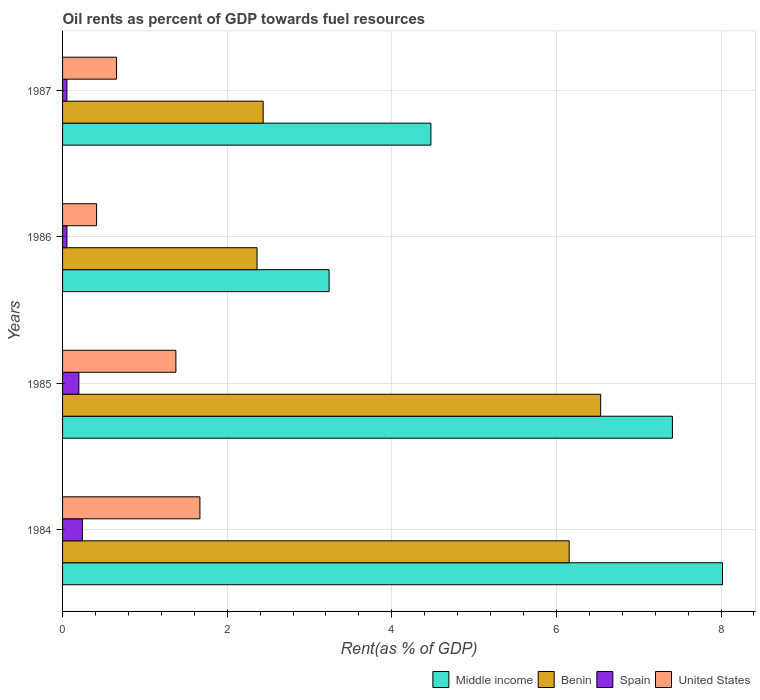How many different coloured bars are there?
Your answer should be compact. 4. How many groups of bars are there?
Ensure brevity in your answer.  4. Are the number of bars per tick equal to the number of legend labels?
Your answer should be compact. Yes. How many bars are there on the 2nd tick from the top?
Provide a short and direct response. 4. In how many cases, is the number of bars for a given year not equal to the number of legend labels?
Make the answer very short. 0. What is the oil rent in Benin in 1987?
Your answer should be compact. 2.44. Across all years, what is the maximum oil rent in Spain?
Your answer should be very brief. 0.24. Across all years, what is the minimum oil rent in United States?
Your response must be concise. 0.41. In which year was the oil rent in Spain maximum?
Your answer should be very brief. 1984. What is the total oil rent in Spain in the graph?
Keep it short and to the point. 0.55. What is the difference between the oil rent in Benin in 1984 and that in 1987?
Provide a short and direct response. 3.72. What is the difference between the oil rent in Benin in 1985 and the oil rent in Spain in 1986?
Give a very brief answer. 6.48. What is the average oil rent in United States per year?
Offer a very short reply. 1.03. In the year 1987, what is the difference between the oil rent in United States and oil rent in Spain?
Ensure brevity in your answer.  0.6. What is the ratio of the oil rent in Benin in 1984 to that in 1986?
Your response must be concise. 2.6. Is the difference between the oil rent in United States in 1984 and 1987 greater than the difference between the oil rent in Spain in 1984 and 1987?
Keep it short and to the point. Yes. What is the difference between the highest and the second highest oil rent in Spain?
Make the answer very short. 0.04. What is the difference between the highest and the lowest oil rent in United States?
Your answer should be compact. 1.26. Is it the case that in every year, the sum of the oil rent in United States and oil rent in Spain is greater than the oil rent in Benin?
Make the answer very short. No. What is the difference between two consecutive major ticks on the X-axis?
Give a very brief answer. 2. Are the values on the major ticks of X-axis written in scientific E-notation?
Give a very brief answer. No. Where does the legend appear in the graph?
Offer a terse response. Bottom right. What is the title of the graph?
Give a very brief answer. Oil rents as percent of GDP towards fuel resources. Does "Trinidad and Tobago" appear as one of the legend labels in the graph?
Keep it short and to the point. No. What is the label or title of the X-axis?
Keep it short and to the point. Rent(as % of GDP). What is the Rent(as % of GDP) in Middle income in 1984?
Give a very brief answer. 8.02. What is the Rent(as % of GDP) of Benin in 1984?
Your answer should be very brief. 6.16. What is the Rent(as % of GDP) of Spain in 1984?
Provide a succinct answer. 0.24. What is the Rent(as % of GDP) of United States in 1984?
Provide a short and direct response. 1.67. What is the Rent(as % of GDP) in Middle income in 1985?
Make the answer very short. 7.41. What is the Rent(as % of GDP) in Benin in 1985?
Provide a succinct answer. 6.54. What is the Rent(as % of GDP) in Spain in 1985?
Make the answer very short. 0.2. What is the Rent(as % of GDP) in United States in 1985?
Make the answer very short. 1.38. What is the Rent(as % of GDP) in Middle income in 1986?
Offer a very short reply. 3.24. What is the Rent(as % of GDP) in Benin in 1986?
Your answer should be very brief. 2.36. What is the Rent(as % of GDP) of Spain in 1986?
Your answer should be compact. 0.05. What is the Rent(as % of GDP) in United States in 1986?
Ensure brevity in your answer.  0.41. What is the Rent(as % of GDP) in Middle income in 1987?
Keep it short and to the point. 4.48. What is the Rent(as % of GDP) of Benin in 1987?
Make the answer very short. 2.44. What is the Rent(as % of GDP) of Spain in 1987?
Keep it short and to the point. 0.05. What is the Rent(as % of GDP) in United States in 1987?
Your answer should be very brief. 0.66. Across all years, what is the maximum Rent(as % of GDP) in Middle income?
Offer a terse response. 8.02. Across all years, what is the maximum Rent(as % of GDP) in Benin?
Provide a short and direct response. 6.54. Across all years, what is the maximum Rent(as % of GDP) of Spain?
Your answer should be compact. 0.24. Across all years, what is the maximum Rent(as % of GDP) of United States?
Make the answer very short. 1.67. Across all years, what is the minimum Rent(as % of GDP) in Middle income?
Offer a terse response. 3.24. Across all years, what is the minimum Rent(as % of GDP) in Benin?
Make the answer very short. 2.36. Across all years, what is the minimum Rent(as % of GDP) of Spain?
Your answer should be very brief. 0.05. Across all years, what is the minimum Rent(as % of GDP) of United States?
Provide a short and direct response. 0.41. What is the total Rent(as % of GDP) in Middle income in the graph?
Offer a terse response. 23.14. What is the total Rent(as % of GDP) of Benin in the graph?
Ensure brevity in your answer.  17.49. What is the total Rent(as % of GDP) in Spain in the graph?
Offer a very short reply. 0.55. What is the total Rent(as % of GDP) of United States in the graph?
Provide a short and direct response. 4.11. What is the difference between the Rent(as % of GDP) in Middle income in 1984 and that in 1985?
Offer a terse response. 0.61. What is the difference between the Rent(as % of GDP) of Benin in 1984 and that in 1985?
Provide a short and direct response. -0.38. What is the difference between the Rent(as % of GDP) of Spain in 1984 and that in 1985?
Offer a terse response. 0.04. What is the difference between the Rent(as % of GDP) in United States in 1984 and that in 1985?
Your answer should be very brief. 0.29. What is the difference between the Rent(as % of GDP) in Middle income in 1984 and that in 1986?
Offer a terse response. 4.78. What is the difference between the Rent(as % of GDP) in Benin in 1984 and that in 1986?
Offer a terse response. 3.79. What is the difference between the Rent(as % of GDP) in Spain in 1984 and that in 1986?
Ensure brevity in your answer.  0.19. What is the difference between the Rent(as % of GDP) in United States in 1984 and that in 1986?
Your answer should be very brief. 1.26. What is the difference between the Rent(as % of GDP) in Middle income in 1984 and that in 1987?
Keep it short and to the point. 3.54. What is the difference between the Rent(as % of GDP) of Benin in 1984 and that in 1987?
Ensure brevity in your answer.  3.72. What is the difference between the Rent(as % of GDP) in Spain in 1984 and that in 1987?
Ensure brevity in your answer.  0.19. What is the difference between the Rent(as % of GDP) in United States in 1984 and that in 1987?
Keep it short and to the point. 1.01. What is the difference between the Rent(as % of GDP) in Middle income in 1985 and that in 1986?
Your answer should be very brief. 4.17. What is the difference between the Rent(as % of GDP) in Benin in 1985 and that in 1986?
Give a very brief answer. 4.17. What is the difference between the Rent(as % of GDP) in Spain in 1985 and that in 1986?
Offer a very short reply. 0.15. What is the difference between the Rent(as % of GDP) of United States in 1985 and that in 1986?
Your response must be concise. 0.96. What is the difference between the Rent(as % of GDP) of Middle income in 1985 and that in 1987?
Provide a succinct answer. 2.93. What is the difference between the Rent(as % of GDP) of Benin in 1985 and that in 1987?
Offer a terse response. 4.1. What is the difference between the Rent(as % of GDP) in Spain in 1985 and that in 1987?
Provide a short and direct response. 0.15. What is the difference between the Rent(as % of GDP) of United States in 1985 and that in 1987?
Offer a very short reply. 0.72. What is the difference between the Rent(as % of GDP) of Middle income in 1986 and that in 1987?
Give a very brief answer. -1.24. What is the difference between the Rent(as % of GDP) in Benin in 1986 and that in 1987?
Your answer should be compact. -0.07. What is the difference between the Rent(as % of GDP) of United States in 1986 and that in 1987?
Offer a very short reply. -0.24. What is the difference between the Rent(as % of GDP) in Middle income in 1984 and the Rent(as % of GDP) in Benin in 1985?
Your response must be concise. 1.48. What is the difference between the Rent(as % of GDP) in Middle income in 1984 and the Rent(as % of GDP) in Spain in 1985?
Provide a succinct answer. 7.82. What is the difference between the Rent(as % of GDP) of Middle income in 1984 and the Rent(as % of GDP) of United States in 1985?
Give a very brief answer. 6.64. What is the difference between the Rent(as % of GDP) in Benin in 1984 and the Rent(as % of GDP) in Spain in 1985?
Offer a very short reply. 5.96. What is the difference between the Rent(as % of GDP) in Benin in 1984 and the Rent(as % of GDP) in United States in 1985?
Make the answer very short. 4.78. What is the difference between the Rent(as % of GDP) of Spain in 1984 and the Rent(as % of GDP) of United States in 1985?
Give a very brief answer. -1.14. What is the difference between the Rent(as % of GDP) of Middle income in 1984 and the Rent(as % of GDP) of Benin in 1986?
Offer a very short reply. 5.66. What is the difference between the Rent(as % of GDP) of Middle income in 1984 and the Rent(as % of GDP) of Spain in 1986?
Your response must be concise. 7.96. What is the difference between the Rent(as % of GDP) of Middle income in 1984 and the Rent(as % of GDP) of United States in 1986?
Ensure brevity in your answer.  7.6. What is the difference between the Rent(as % of GDP) of Benin in 1984 and the Rent(as % of GDP) of Spain in 1986?
Your answer should be compact. 6.1. What is the difference between the Rent(as % of GDP) in Benin in 1984 and the Rent(as % of GDP) in United States in 1986?
Ensure brevity in your answer.  5.74. What is the difference between the Rent(as % of GDP) in Spain in 1984 and the Rent(as % of GDP) in United States in 1986?
Your answer should be very brief. -0.17. What is the difference between the Rent(as % of GDP) of Middle income in 1984 and the Rent(as % of GDP) of Benin in 1987?
Provide a short and direct response. 5.58. What is the difference between the Rent(as % of GDP) of Middle income in 1984 and the Rent(as % of GDP) of Spain in 1987?
Make the answer very short. 7.97. What is the difference between the Rent(as % of GDP) of Middle income in 1984 and the Rent(as % of GDP) of United States in 1987?
Provide a succinct answer. 7.36. What is the difference between the Rent(as % of GDP) of Benin in 1984 and the Rent(as % of GDP) of Spain in 1987?
Your response must be concise. 6.1. What is the difference between the Rent(as % of GDP) in Benin in 1984 and the Rent(as % of GDP) in United States in 1987?
Provide a succinct answer. 5.5. What is the difference between the Rent(as % of GDP) of Spain in 1984 and the Rent(as % of GDP) of United States in 1987?
Offer a terse response. -0.42. What is the difference between the Rent(as % of GDP) in Middle income in 1985 and the Rent(as % of GDP) in Benin in 1986?
Make the answer very short. 5.05. What is the difference between the Rent(as % of GDP) of Middle income in 1985 and the Rent(as % of GDP) of Spain in 1986?
Give a very brief answer. 7.36. What is the difference between the Rent(as % of GDP) of Middle income in 1985 and the Rent(as % of GDP) of United States in 1986?
Make the answer very short. 7. What is the difference between the Rent(as % of GDP) of Benin in 1985 and the Rent(as % of GDP) of Spain in 1986?
Provide a short and direct response. 6.48. What is the difference between the Rent(as % of GDP) of Benin in 1985 and the Rent(as % of GDP) of United States in 1986?
Offer a very short reply. 6.12. What is the difference between the Rent(as % of GDP) in Spain in 1985 and the Rent(as % of GDP) in United States in 1986?
Provide a succinct answer. -0.21. What is the difference between the Rent(as % of GDP) of Middle income in 1985 and the Rent(as % of GDP) of Benin in 1987?
Offer a very short reply. 4.97. What is the difference between the Rent(as % of GDP) of Middle income in 1985 and the Rent(as % of GDP) of Spain in 1987?
Your answer should be very brief. 7.36. What is the difference between the Rent(as % of GDP) of Middle income in 1985 and the Rent(as % of GDP) of United States in 1987?
Provide a short and direct response. 6.75. What is the difference between the Rent(as % of GDP) in Benin in 1985 and the Rent(as % of GDP) in Spain in 1987?
Provide a succinct answer. 6.49. What is the difference between the Rent(as % of GDP) of Benin in 1985 and the Rent(as % of GDP) of United States in 1987?
Ensure brevity in your answer.  5.88. What is the difference between the Rent(as % of GDP) in Spain in 1985 and the Rent(as % of GDP) in United States in 1987?
Your response must be concise. -0.46. What is the difference between the Rent(as % of GDP) in Middle income in 1986 and the Rent(as % of GDP) in Benin in 1987?
Offer a terse response. 0.8. What is the difference between the Rent(as % of GDP) of Middle income in 1986 and the Rent(as % of GDP) of Spain in 1987?
Give a very brief answer. 3.19. What is the difference between the Rent(as % of GDP) of Middle income in 1986 and the Rent(as % of GDP) of United States in 1987?
Offer a very short reply. 2.58. What is the difference between the Rent(as % of GDP) in Benin in 1986 and the Rent(as % of GDP) in Spain in 1987?
Provide a short and direct response. 2.31. What is the difference between the Rent(as % of GDP) of Benin in 1986 and the Rent(as % of GDP) of United States in 1987?
Your response must be concise. 1.71. What is the difference between the Rent(as % of GDP) of Spain in 1986 and the Rent(as % of GDP) of United States in 1987?
Provide a succinct answer. -0.6. What is the average Rent(as % of GDP) of Middle income per year?
Provide a succinct answer. 5.79. What is the average Rent(as % of GDP) in Benin per year?
Give a very brief answer. 4.37. What is the average Rent(as % of GDP) of Spain per year?
Your answer should be compact. 0.14. What is the average Rent(as % of GDP) in United States per year?
Offer a terse response. 1.03. In the year 1984, what is the difference between the Rent(as % of GDP) in Middle income and Rent(as % of GDP) in Benin?
Provide a succinct answer. 1.86. In the year 1984, what is the difference between the Rent(as % of GDP) in Middle income and Rent(as % of GDP) in Spain?
Make the answer very short. 7.78. In the year 1984, what is the difference between the Rent(as % of GDP) in Middle income and Rent(as % of GDP) in United States?
Offer a very short reply. 6.35. In the year 1984, what is the difference between the Rent(as % of GDP) in Benin and Rent(as % of GDP) in Spain?
Provide a short and direct response. 5.91. In the year 1984, what is the difference between the Rent(as % of GDP) of Benin and Rent(as % of GDP) of United States?
Make the answer very short. 4.49. In the year 1984, what is the difference between the Rent(as % of GDP) of Spain and Rent(as % of GDP) of United States?
Your answer should be compact. -1.43. In the year 1985, what is the difference between the Rent(as % of GDP) of Middle income and Rent(as % of GDP) of Benin?
Offer a terse response. 0.87. In the year 1985, what is the difference between the Rent(as % of GDP) in Middle income and Rent(as % of GDP) in Spain?
Offer a terse response. 7.21. In the year 1985, what is the difference between the Rent(as % of GDP) of Middle income and Rent(as % of GDP) of United States?
Give a very brief answer. 6.03. In the year 1985, what is the difference between the Rent(as % of GDP) of Benin and Rent(as % of GDP) of Spain?
Your response must be concise. 6.34. In the year 1985, what is the difference between the Rent(as % of GDP) in Benin and Rent(as % of GDP) in United States?
Your answer should be very brief. 5.16. In the year 1985, what is the difference between the Rent(as % of GDP) in Spain and Rent(as % of GDP) in United States?
Offer a very short reply. -1.18. In the year 1986, what is the difference between the Rent(as % of GDP) in Middle income and Rent(as % of GDP) in Benin?
Give a very brief answer. 0.88. In the year 1986, what is the difference between the Rent(as % of GDP) of Middle income and Rent(as % of GDP) of Spain?
Keep it short and to the point. 3.19. In the year 1986, what is the difference between the Rent(as % of GDP) of Middle income and Rent(as % of GDP) of United States?
Ensure brevity in your answer.  2.83. In the year 1986, what is the difference between the Rent(as % of GDP) of Benin and Rent(as % of GDP) of Spain?
Give a very brief answer. 2.31. In the year 1986, what is the difference between the Rent(as % of GDP) in Benin and Rent(as % of GDP) in United States?
Give a very brief answer. 1.95. In the year 1986, what is the difference between the Rent(as % of GDP) of Spain and Rent(as % of GDP) of United States?
Make the answer very short. -0.36. In the year 1987, what is the difference between the Rent(as % of GDP) of Middle income and Rent(as % of GDP) of Benin?
Your response must be concise. 2.04. In the year 1987, what is the difference between the Rent(as % of GDP) in Middle income and Rent(as % of GDP) in Spain?
Your answer should be compact. 4.42. In the year 1987, what is the difference between the Rent(as % of GDP) in Middle income and Rent(as % of GDP) in United States?
Give a very brief answer. 3.82. In the year 1987, what is the difference between the Rent(as % of GDP) in Benin and Rent(as % of GDP) in Spain?
Your response must be concise. 2.38. In the year 1987, what is the difference between the Rent(as % of GDP) of Benin and Rent(as % of GDP) of United States?
Offer a very short reply. 1.78. In the year 1987, what is the difference between the Rent(as % of GDP) in Spain and Rent(as % of GDP) in United States?
Offer a terse response. -0.6. What is the ratio of the Rent(as % of GDP) in Middle income in 1984 to that in 1985?
Give a very brief answer. 1.08. What is the ratio of the Rent(as % of GDP) of Benin in 1984 to that in 1985?
Give a very brief answer. 0.94. What is the ratio of the Rent(as % of GDP) of Spain in 1984 to that in 1985?
Your answer should be very brief. 1.21. What is the ratio of the Rent(as % of GDP) in United States in 1984 to that in 1985?
Your response must be concise. 1.21. What is the ratio of the Rent(as % of GDP) in Middle income in 1984 to that in 1986?
Your answer should be very brief. 2.48. What is the ratio of the Rent(as % of GDP) in Benin in 1984 to that in 1986?
Your answer should be very brief. 2.6. What is the ratio of the Rent(as % of GDP) in Spain in 1984 to that in 1986?
Give a very brief answer. 4.54. What is the ratio of the Rent(as % of GDP) of United States in 1984 to that in 1986?
Offer a terse response. 4.04. What is the ratio of the Rent(as % of GDP) of Middle income in 1984 to that in 1987?
Make the answer very short. 1.79. What is the ratio of the Rent(as % of GDP) in Benin in 1984 to that in 1987?
Make the answer very short. 2.53. What is the ratio of the Rent(as % of GDP) of Spain in 1984 to that in 1987?
Your answer should be very brief. 4.56. What is the ratio of the Rent(as % of GDP) of United States in 1984 to that in 1987?
Make the answer very short. 2.54. What is the ratio of the Rent(as % of GDP) of Middle income in 1985 to that in 1986?
Your response must be concise. 2.29. What is the ratio of the Rent(as % of GDP) of Benin in 1985 to that in 1986?
Your answer should be very brief. 2.77. What is the ratio of the Rent(as % of GDP) in Spain in 1985 to that in 1986?
Offer a terse response. 3.74. What is the ratio of the Rent(as % of GDP) in United States in 1985 to that in 1986?
Give a very brief answer. 3.33. What is the ratio of the Rent(as % of GDP) in Middle income in 1985 to that in 1987?
Offer a very short reply. 1.66. What is the ratio of the Rent(as % of GDP) in Benin in 1985 to that in 1987?
Offer a very short reply. 2.68. What is the ratio of the Rent(as % of GDP) in Spain in 1985 to that in 1987?
Ensure brevity in your answer.  3.76. What is the ratio of the Rent(as % of GDP) of United States in 1985 to that in 1987?
Your response must be concise. 2.1. What is the ratio of the Rent(as % of GDP) of Middle income in 1986 to that in 1987?
Your answer should be compact. 0.72. What is the ratio of the Rent(as % of GDP) in Benin in 1986 to that in 1987?
Provide a succinct answer. 0.97. What is the ratio of the Rent(as % of GDP) of United States in 1986 to that in 1987?
Your answer should be compact. 0.63. What is the difference between the highest and the second highest Rent(as % of GDP) of Middle income?
Provide a short and direct response. 0.61. What is the difference between the highest and the second highest Rent(as % of GDP) in Benin?
Ensure brevity in your answer.  0.38. What is the difference between the highest and the second highest Rent(as % of GDP) in Spain?
Your response must be concise. 0.04. What is the difference between the highest and the second highest Rent(as % of GDP) of United States?
Provide a short and direct response. 0.29. What is the difference between the highest and the lowest Rent(as % of GDP) in Middle income?
Your answer should be very brief. 4.78. What is the difference between the highest and the lowest Rent(as % of GDP) in Benin?
Your answer should be compact. 4.17. What is the difference between the highest and the lowest Rent(as % of GDP) in Spain?
Give a very brief answer. 0.19. What is the difference between the highest and the lowest Rent(as % of GDP) in United States?
Provide a succinct answer. 1.26. 